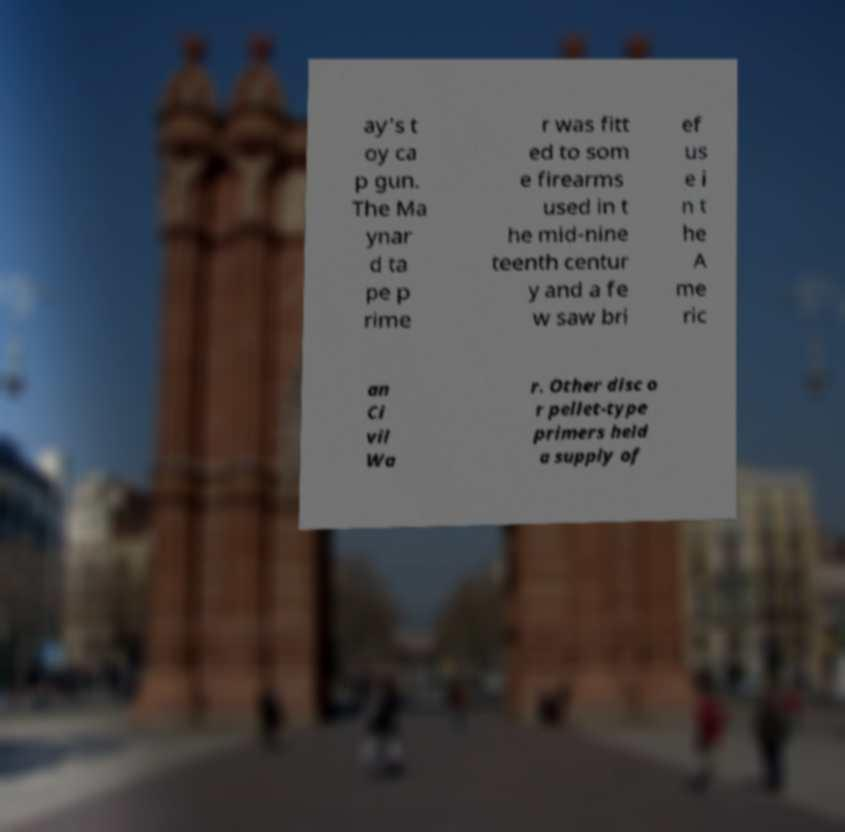For documentation purposes, I need the text within this image transcribed. Could you provide that? ay's t oy ca p gun. The Ma ynar d ta pe p rime r was fitt ed to som e firearms used in t he mid-nine teenth centur y and a fe w saw bri ef us e i n t he A me ric an Ci vil Wa r. Other disc o r pellet-type primers held a supply of 